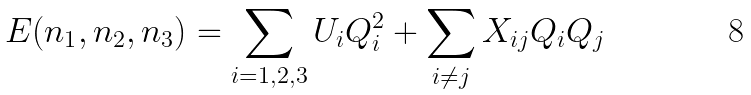Convert formula to latex. <formula><loc_0><loc_0><loc_500><loc_500>E ( n _ { 1 } , n _ { 2 } , n _ { 3 } ) = \sum _ { i = 1 , 2 , 3 } U _ { i } Q _ { i } ^ { 2 } + \sum _ { i \ne j } X _ { i j } Q _ { i } Q _ { j }</formula> 